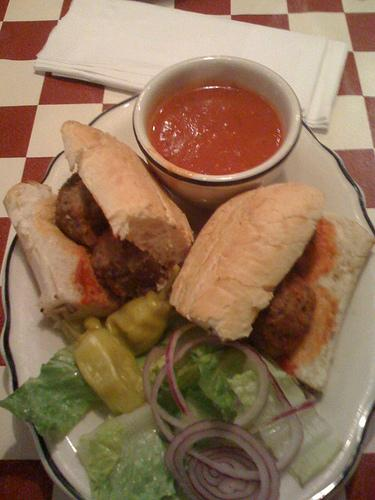What type of pepper is on the plate? Please explain your reasoning. pepperoncini. The pepper is a sweet pepper that is similar to the banana pepper. 